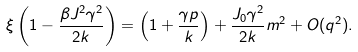<formula> <loc_0><loc_0><loc_500><loc_500>\xi \left ( 1 - \frac { \beta J ^ { 2 } \gamma ^ { 2 } } { 2 k } \right ) = \left ( 1 + \frac { \gamma p } { k } \right ) + \frac { J _ { 0 } \gamma ^ { 2 } } { 2 k } m ^ { 2 } + O ( q ^ { 2 } ) .</formula> 